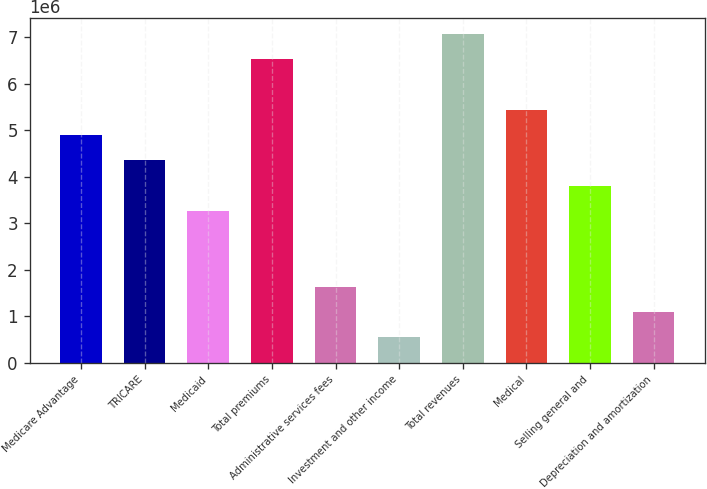<chart> <loc_0><loc_0><loc_500><loc_500><bar_chart><fcel>Medicare Advantage<fcel>TRICARE<fcel>Medicaid<fcel>Total premiums<fcel>Administrative services fees<fcel>Investment and other income<fcel>Total revenues<fcel>Medical<fcel>Selling general and<fcel>Depreciation and amortization<nl><fcel>4.89267e+06<fcel>4.34939e+06<fcel>3.26285e+06<fcel>6.52249e+06<fcel>1.63303e+06<fcel>546484<fcel>7.06576e+06<fcel>5.43594e+06<fcel>3.80612e+06<fcel>1.08976e+06<nl></chart> 